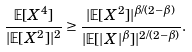<formula> <loc_0><loc_0><loc_500><loc_500>\frac { \mathbb { E } [ X ^ { 4 } ] } { | \mathbb { E } [ X ^ { 2 } ] | ^ { 2 } } \geq \frac { | \mathbb { E } [ X ^ { 2 } ] | ^ { \beta / ( 2 - \beta ) } } { | \mathbb { E } [ | X | ^ { \beta } ] | ^ { 2 / ( 2 - \beta ) } } .</formula> 